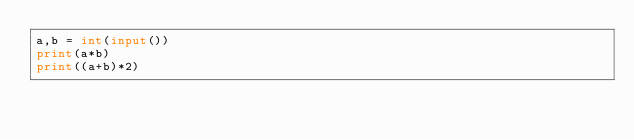<code> <loc_0><loc_0><loc_500><loc_500><_Python_>a,b = int(input())
print(a*b)
print((a+b)*2)</code> 